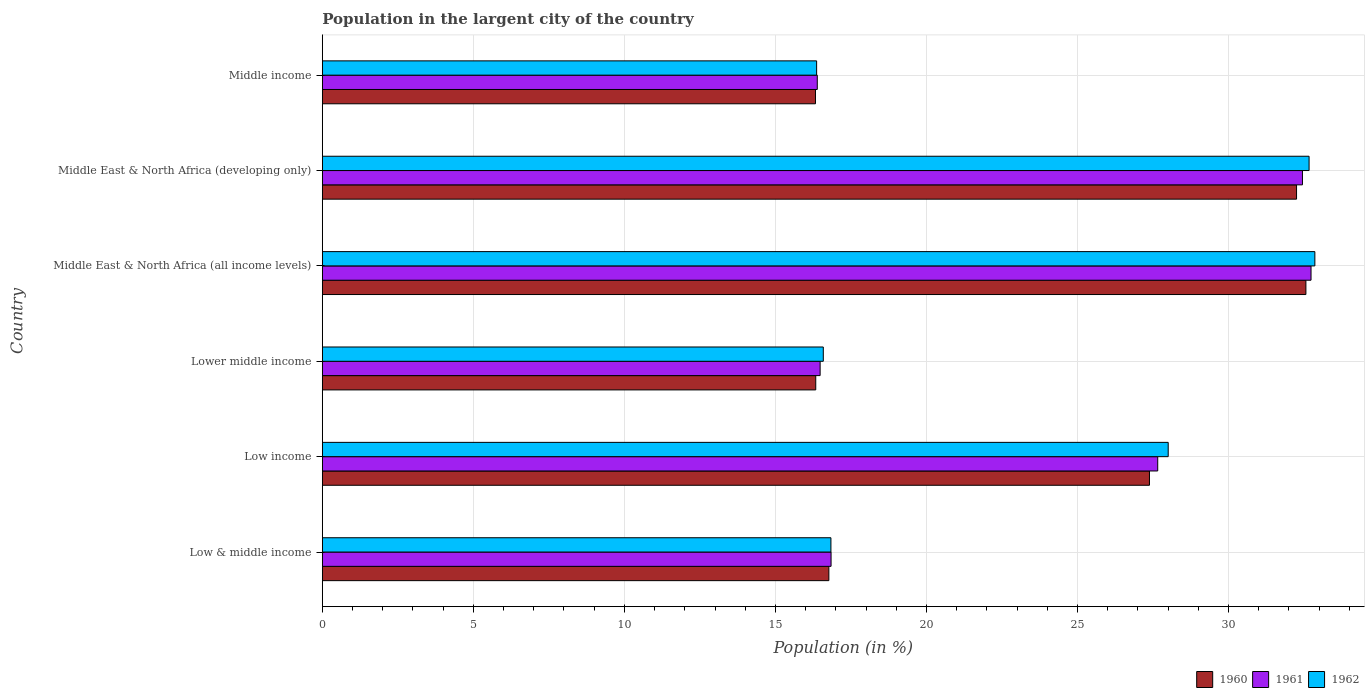How many different coloured bars are there?
Your response must be concise. 3. How many groups of bars are there?
Offer a terse response. 6. Are the number of bars on each tick of the Y-axis equal?
Give a very brief answer. Yes. What is the label of the 2nd group of bars from the top?
Keep it short and to the point. Middle East & North Africa (developing only). In how many cases, is the number of bars for a given country not equal to the number of legend labels?
Give a very brief answer. 0. What is the percentage of population in the largent city in 1962 in Middle East & North Africa (developing only)?
Provide a short and direct response. 32.67. Across all countries, what is the maximum percentage of population in the largent city in 1960?
Your response must be concise. 32.56. Across all countries, what is the minimum percentage of population in the largent city in 1962?
Keep it short and to the point. 16.36. In which country was the percentage of population in the largent city in 1961 maximum?
Provide a succinct answer. Middle East & North Africa (all income levels). In which country was the percentage of population in the largent city in 1962 minimum?
Your response must be concise. Middle income. What is the total percentage of population in the largent city in 1961 in the graph?
Offer a very short reply. 142.55. What is the difference between the percentage of population in the largent city in 1962 in Lower middle income and that in Middle income?
Your response must be concise. 0.22. What is the difference between the percentage of population in the largent city in 1962 in Middle income and the percentage of population in the largent city in 1960 in Low & middle income?
Your answer should be compact. -0.41. What is the average percentage of population in the largent city in 1960 per country?
Offer a terse response. 23.61. What is the difference between the percentage of population in the largent city in 1962 and percentage of population in the largent city in 1960 in Low income?
Give a very brief answer. 0.62. What is the ratio of the percentage of population in the largent city in 1960 in Low & middle income to that in Lower middle income?
Give a very brief answer. 1.03. Is the percentage of population in the largent city in 1960 in Low income less than that in Lower middle income?
Your answer should be compact. No. What is the difference between the highest and the second highest percentage of population in the largent city in 1961?
Keep it short and to the point. 0.28. What is the difference between the highest and the lowest percentage of population in the largent city in 1962?
Provide a short and direct response. 16.5. Is the sum of the percentage of population in the largent city in 1960 in Low & middle income and Middle East & North Africa (developing only) greater than the maximum percentage of population in the largent city in 1962 across all countries?
Keep it short and to the point. Yes. What does the 2nd bar from the top in Lower middle income represents?
Keep it short and to the point. 1961. What does the 1st bar from the bottom in Low income represents?
Your answer should be very brief. 1960. How many bars are there?
Provide a short and direct response. 18. How many countries are there in the graph?
Provide a succinct answer. 6. What is the difference between two consecutive major ticks on the X-axis?
Give a very brief answer. 5. Are the values on the major ticks of X-axis written in scientific E-notation?
Offer a terse response. No. How many legend labels are there?
Your answer should be very brief. 3. How are the legend labels stacked?
Ensure brevity in your answer.  Horizontal. What is the title of the graph?
Ensure brevity in your answer.  Population in the largent city of the country. Does "2010" appear as one of the legend labels in the graph?
Your response must be concise. No. What is the Population (in %) of 1960 in Low & middle income?
Provide a succinct answer. 16.77. What is the Population (in %) in 1961 in Low & middle income?
Offer a terse response. 16.84. What is the Population (in %) of 1962 in Low & middle income?
Offer a very short reply. 16.84. What is the Population (in %) of 1960 in Low income?
Make the answer very short. 27.38. What is the Population (in %) of 1961 in Low income?
Your response must be concise. 27.66. What is the Population (in %) of 1962 in Low income?
Provide a succinct answer. 28. What is the Population (in %) in 1960 in Lower middle income?
Ensure brevity in your answer.  16.34. What is the Population (in %) in 1961 in Lower middle income?
Ensure brevity in your answer.  16.48. What is the Population (in %) of 1962 in Lower middle income?
Offer a very short reply. 16.59. What is the Population (in %) of 1960 in Middle East & North Africa (all income levels)?
Keep it short and to the point. 32.56. What is the Population (in %) in 1961 in Middle East & North Africa (all income levels)?
Provide a short and direct response. 32.73. What is the Population (in %) of 1962 in Middle East & North Africa (all income levels)?
Your answer should be compact. 32.86. What is the Population (in %) in 1960 in Middle East & North Africa (developing only)?
Offer a terse response. 32.25. What is the Population (in %) in 1961 in Middle East & North Africa (developing only)?
Make the answer very short. 32.45. What is the Population (in %) of 1962 in Middle East & North Africa (developing only)?
Offer a terse response. 32.67. What is the Population (in %) of 1960 in Middle income?
Provide a succinct answer. 16.33. What is the Population (in %) of 1961 in Middle income?
Provide a succinct answer. 16.39. What is the Population (in %) in 1962 in Middle income?
Give a very brief answer. 16.36. Across all countries, what is the maximum Population (in %) of 1960?
Make the answer very short. 32.56. Across all countries, what is the maximum Population (in %) of 1961?
Ensure brevity in your answer.  32.73. Across all countries, what is the maximum Population (in %) of 1962?
Offer a terse response. 32.86. Across all countries, what is the minimum Population (in %) in 1960?
Offer a terse response. 16.33. Across all countries, what is the minimum Population (in %) of 1961?
Offer a terse response. 16.39. Across all countries, what is the minimum Population (in %) of 1962?
Provide a short and direct response. 16.36. What is the total Population (in %) of 1960 in the graph?
Your answer should be compact. 141.63. What is the total Population (in %) of 1961 in the graph?
Provide a succinct answer. 142.55. What is the total Population (in %) in 1962 in the graph?
Your answer should be very brief. 143.32. What is the difference between the Population (in %) of 1960 in Low & middle income and that in Low income?
Make the answer very short. -10.61. What is the difference between the Population (in %) in 1961 in Low & middle income and that in Low income?
Your response must be concise. -10.81. What is the difference between the Population (in %) in 1962 in Low & middle income and that in Low income?
Your answer should be very brief. -11.17. What is the difference between the Population (in %) in 1960 in Low & middle income and that in Lower middle income?
Keep it short and to the point. 0.43. What is the difference between the Population (in %) in 1961 in Low & middle income and that in Lower middle income?
Offer a terse response. 0.36. What is the difference between the Population (in %) in 1962 in Low & middle income and that in Lower middle income?
Provide a short and direct response. 0.25. What is the difference between the Population (in %) in 1960 in Low & middle income and that in Middle East & North Africa (all income levels)?
Offer a very short reply. -15.79. What is the difference between the Population (in %) of 1961 in Low & middle income and that in Middle East & North Africa (all income levels)?
Offer a very short reply. -15.89. What is the difference between the Population (in %) in 1962 in Low & middle income and that in Middle East & North Africa (all income levels)?
Provide a succinct answer. -16.02. What is the difference between the Population (in %) of 1960 in Low & middle income and that in Middle East & North Africa (developing only)?
Offer a very short reply. -15.48. What is the difference between the Population (in %) in 1961 in Low & middle income and that in Middle East & North Africa (developing only)?
Your answer should be compact. -15.61. What is the difference between the Population (in %) in 1962 in Low & middle income and that in Middle East & North Africa (developing only)?
Your answer should be compact. -15.83. What is the difference between the Population (in %) of 1960 in Low & middle income and that in Middle income?
Keep it short and to the point. 0.44. What is the difference between the Population (in %) in 1961 in Low & middle income and that in Middle income?
Offer a very short reply. 0.46. What is the difference between the Population (in %) in 1962 in Low & middle income and that in Middle income?
Your response must be concise. 0.47. What is the difference between the Population (in %) of 1960 in Low income and that in Lower middle income?
Your response must be concise. 11.05. What is the difference between the Population (in %) of 1961 in Low income and that in Lower middle income?
Give a very brief answer. 11.18. What is the difference between the Population (in %) of 1962 in Low income and that in Lower middle income?
Provide a short and direct response. 11.42. What is the difference between the Population (in %) in 1960 in Low income and that in Middle East & North Africa (all income levels)?
Offer a terse response. -5.18. What is the difference between the Population (in %) in 1961 in Low income and that in Middle East & North Africa (all income levels)?
Your answer should be very brief. -5.08. What is the difference between the Population (in %) of 1962 in Low income and that in Middle East & North Africa (all income levels)?
Your answer should be compact. -4.86. What is the difference between the Population (in %) in 1960 in Low income and that in Middle East & North Africa (developing only)?
Offer a terse response. -4.87. What is the difference between the Population (in %) of 1961 in Low income and that in Middle East & North Africa (developing only)?
Ensure brevity in your answer.  -4.79. What is the difference between the Population (in %) in 1962 in Low income and that in Middle East & North Africa (developing only)?
Provide a succinct answer. -4.66. What is the difference between the Population (in %) of 1960 in Low income and that in Middle income?
Provide a short and direct response. 11.06. What is the difference between the Population (in %) in 1961 in Low income and that in Middle income?
Offer a terse response. 11.27. What is the difference between the Population (in %) in 1962 in Low income and that in Middle income?
Give a very brief answer. 11.64. What is the difference between the Population (in %) of 1960 in Lower middle income and that in Middle East & North Africa (all income levels)?
Ensure brevity in your answer.  -16.23. What is the difference between the Population (in %) in 1961 in Lower middle income and that in Middle East & North Africa (all income levels)?
Ensure brevity in your answer.  -16.25. What is the difference between the Population (in %) of 1962 in Lower middle income and that in Middle East & North Africa (all income levels)?
Offer a very short reply. -16.27. What is the difference between the Population (in %) in 1960 in Lower middle income and that in Middle East & North Africa (developing only)?
Ensure brevity in your answer.  -15.92. What is the difference between the Population (in %) of 1961 in Lower middle income and that in Middle East & North Africa (developing only)?
Make the answer very short. -15.97. What is the difference between the Population (in %) in 1962 in Lower middle income and that in Middle East & North Africa (developing only)?
Provide a short and direct response. -16.08. What is the difference between the Population (in %) of 1960 in Lower middle income and that in Middle income?
Provide a short and direct response. 0.01. What is the difference between the Population (in %) of 1961 in Lower middle income and that in Middle income?
Make the answer very short. 0.09. What is the difference between the Population (in %) of 1962 in Lower middle income and that in Middle income?
Provide a short and direct response. 0.22. What is the difference between the Population (in %) in 1960 in Middle East & North Africa (all income levels) and that in Middle East & North Africa (developing only)?
Your answer should be compact. 0.31. What is the difference between the Population (in %) of 1961 in Middle East & North Africa (all income levels) and that in Middle East & North Africa (developing only)?
Offer a terse response. 0.28. What is the difference between the Population (in %) in 1962 in Middle East & North Africa (all income levels) and that in Middle East & North Africa (developing only)?
Keep it short and to the point. 0.19. What is the difference between the Population (in %) of 1960 in Middle East & North Africa (all income levels) and that in Middle income?
Provide a short and direct response. 16.24. What is the difference between the Population (in %) in 1961 in Middle East & North Africa (all income levels) and that in Middle income?
Your response must be concise. 16.35. What is the difference between the Population (in %) in 1962 in Middle East & North Africa (all income levels) and that in Middle income?
Make the answer very short. 16.5. What is the difference between the Population (in %) in 1960 in Middle East & North Africa (developing only) and that in Middle income?
Give a very brief answer. 15.93. What is the difference between the Population (in %) of 1961 in Middle East & North Africa (developing only) and that in Middle income?
Provide a short and direct response. 16.06. What is the difference between the Population (in %) of 1962 in Middle East & North Africa (developing only) and that in Middle income?
Your answer should be very brief. 16.3. What is the difference between the Population (in %) of 1960 in Low & middle income and the Population (in %) of 1961 in Low income?
Keep it short and to the point. -10.89. What is the difference between the Population (in %) of 1960 in Low & middle income and the Population (in %) of 1962 in Low income?
Provide a succinct answer. -11.23. What is the difference between the Population (in %) of 1961 in Low & middle income and the Population (in %) of 1962 in Low income?
Make the answer very short. -11.16. What is the difference between the Population (in %) of 1960 in Low & middle income and the Population (in %) of 1961 in Lower middle income?
Offer a very short reply. 0.29. What is the difference between the Population (in %) of 1960 in Low & middle income and the Population (in %) of 1962 in Lower middle income?
Your answer should be very brief. 0.18. What is the difference between the Population (in %) in 1961 in Low & middle income and the Population (in %) in 1962 in Lower middle income?
Provide a succinct answer. 0.26. What is the difference between the Population (in %) of 1960 in Low & middle income and the Population (in %) of 1961 in Middle East & North Africa (all income levels)?
Offer a terse response. -15.96. What is the difference between the Population (in %) of 1960 in Low & middle income and the Population (in %) of 1962 in Middle East & North Africa (all income levels)?
Provide a short and direct response. -16.09. What is the difference between the Population (in %) in 1961 in Low & middle income and the Population (in %) in 1962 in Middle East & North Africa (all income levels)?
Provide a short and direct response. -16.02. What is the difference between the Population (in %) in 1960 in Low & middle income and the Population (in %) in 1961 in Middle East & North Africa (developing only)?
Offer a terse response. -15.68. What is the difference between the Population (in %) in 1960 in Low & middle income and the Population (in %) in 1962 in Middle East & North Africa (developing only)?
Provide a succinct answer. -15.9. What is the difference between the Population (in %) in 1961 in Low & middle income and the Population (in %) in 1962 in Middle East & North Africa (developing only)?
Keep it short and to the point. -15.83. What is the difference between the Population (in %) in 1960 in Low & middle income and the Population (in %) in 1961 in Middle income?
Make the answer very short. 0.38. What is the difference between the Population (in %) of 1960 in Low & middle income and the Population (in %) of 1962 in Middle income?
Give a very brief answer. 0.41. What is the difference between the Population (in %) in 1961 in Low & middle income and the Population (in %) in 1962 in Middle income?
Make the answer very short. 0.48. What is the difference between the Population (in %) of 1960 in Low income and the Population (in %) of 1961 in Lower middle income?
Make the answer very short. 10.9. What is the difference between the Population (in %) in 1960 in Low income and the Population (in %) in 1962 in Lower middle income?
Keep it short and to the point. 10.8. What is the difference between the Population (in %) in 1961 in Low income and the Population (in %) in 1962 in Lower middle income?
Ensure brevity in your answer.  11.07. What is the difference between the Population (in %) in 1960 in Low income and the Population (in %) in 1961 in Middle East & North Africa (all income levels)?
Your answer should be very brief. -5.35. What is the difference between the Population (in %) in 1960 in Low income and the Population (in %) in 1962 in Middle East & North Africa (all income levels)?
Your answer should be compact. -5.48. What is the difference between the Population (in %) of 1961 in Low income and the Population (in %) of 1962 in Middle East & North Africa (all income levels)?
Offer a very short reply. -5.2. What is the difference between the Population (in %) in 1960 in Low income and the Population (in %) in 1961 in Middle East & North Africa (developing only)?
Offer a terse response. -5.07. What is the difference between the Population (in %) of 1960 in Low income and the Population (in %) of 1962 in Middle East & North Africa (developing only)?
Keep it short and to the point. -5.28. What is the difference between the Population (in %) of 1961 in Low income and the Population (in %) of 1962 in Middle East & North Africa (developing only)?
Give a very brief answer. -5.01. What is the difference between the Population (in %) in 1960 in Low income and the Population (in %) in 1961 in Middle income?
Give a very brief answer. 11. What is the difference between the Population (in %) of 1960 in Low income and the Population (in %) of 1962 in Middle income?
Your answer should be very brief. 11.02. What is the difference between the Population (in %) of 1961 in Low income and the Population (in %) of 1962 in Middle income?
Your answer should be compact. 11.29. What is the difference between the Population (in %) of 1960 in Lower middle income and the Population (in %) of 1961 in Middle East & North Africa (all income levels)?
Keep it short and to the point. -16.4. What is the difference between the Population (in %) in 1960 in Lower middle income and the Population (in %) in 1962 in Middle East & North Africa (all income levels)?
Ensure brevity in your answer.  -16.52. What is the difference between the Population (in %) of 1961 in Lower middle income and the Population (in %) of 1962 in Middle East & North Africa (all income levels)?
Provide a short and direct response. -16.38. What is the difference between the Population (in %) of 1960 in Lower middle income and the Population (in %) of 1961 in Middle East & North Africa (developing only)?
Give a very brief answer. -16.11. What is the difference between the Population (in %) in 1960 in Lower middle income and the Population (in %) in 1962 in Middle East & North Africa (developing only)?
Provide a succinct answer. -16.33. What is the difference between the Population (in %) of 1961 in Lower middle income and the Population (in %) of 1962 in Middle East & North Africa (developing only)?
Provide a short and direct response. -16.19. What is the difference between the Population (in %) in 1960 in Lower middle income and the Population (in %) in 1961 in Middle income?
Make the answer very short. -0.05. What is the difference between the Population (in %) in 1960 in Lower middle income and the Population (in %) in 1962 in Middle income?
Make the answer very short. -0.03. What is the difference between the Population (in %) in 1961 in Lower middle income and the Population (in %) in 1962 in Middle income?
Offer a terse response. 0.12. What is the difference between the Population (in %) in 1960 in Middle East & North Africa (all income levels) and the Population (in %) in 1961 in Middle East & North Africa (developing only)?
Offer a terse response. 0.11. What is the difference between the Population (in %) of 1960 in Middle East & North Africa (all income levels) and the Population (in %) of 1962 in Middle East & North Africa (developing only)?
Offer a terse response. -0.1. What is the difference between the Population (in %) of 1961 in Middle East & North Africa (all income levels) and the Population (in %) of 1962 in Middle East & North Africa (developing only)?
Offer a very short reply. 0.06. What is the difference between the Population (in %) of 1960 in Middle East & North Africa (all income levels) and the Population (in %) of 1961 in Middle income?
Provide a succinct answer. 16.18. What is the difference between the Population (in %) in 1960 in Middle East & North Africa (all income levels) and the Population (in %) in 1962 in Middle income?
Provide a succinct answer. 16.2. What is the difference between the Population (in %) in 1961 in Middle East & North Africa (all income levels) and the Population (in %) in 1962 in Middle income?
Your answer should be compact. 16.37. What is the difference between the Population (in %) of 1960 in Middle East & North Africa (developing only) and the Population (in %) of 1961 in Middle income?
Provide a succinct answer. 15.87. What is the difference between the Population (in %) in 1960 in Middle East & North Africa (developing only) and the Population (in %) in 1962 in Middle income?
Ensure brevity in your answer.  15.89. What is the difference between the Population (in %) of 1961 in Middle East & North Africa (developing only) and the Population (in %) of 1962 in Middle income?
Your answer should be compact. 16.08. What is the average Population (in %) in 1960 per country?
Ensure brevity in your answer.  23.61. What is the average Population (in %) in 1961 per country?
Give a very brief answer. 23.76. What is the average Population (in %) of 1962 per country?
Make the answer very short. 23.89. What is the difference between the Population (in %) of 1960 and Population (in %) of 1961 in Low & middle income?
Provide a short and direct response. -0.07. What is the difference between the Population (in %) of 1960 and Population (in %) of 1962 in Low & middle income?
Offer a terse response. -0.07. What is the difference between the Population (in %) of 1961 and Population (in %) of 1962 in Low & middle income?
Make the answer very short. 0. What is the difference between the Population (in %) in 1960 and Population (in %) in 1961 in Low income?
Your answer should be very brief. -0.27. What is the difference between the Population (in %) in 1960 and Population (in %) in 1962 in Low income?
Keep it short and to the point. -0.62. What is the difference between the Population (in %) in 1961 and Population (in %) in 1962 in Low income?
Your answer should be very brief. -0.35. What is the difference between the Population (in %) of 1960 and Population (in %) of 1961 in Lower middle income?
Make the answer very short. -0.15. What is the difference between the Population (in %) of 1960 and Population (in %) of 1962 in Lower middle income?
Ensure brevity in your answer.  -0.25. What is the difference between the Population (in %) of 1961 and Population (in %) of 1962 in Lower middle income?
Your answer should be compact. -0.1. What is the difference between the Population (in %) in 1960 and Population (in %) in 1961 in Middle East & North Africa (all income levels)?
Your answer should be very brief. -0.17. What is the difference between the Population (in %) in 1960 and Population (in %) in 1962 in Middle East & North Africa (all income levels)?
Offer a terse response. -0.3. What is the difference between the Population (in %) in 1961 and Population (in %) in 1962 in Middle East & North Africa (all income levels)?
Make the answer very short. -0.13. What is the difference between the Population (in %) in 1960 and Population (in %) in 1961 in Middle East & North Africa (developing only)?
Keep it short and to the point. -0.2. What is the difference between the Population (in %) of 1960 and Population (in %) of 1962 in Middle East & North Africa (developing only)?
Offer a terse response. -0.41. What is the difference between the Population (in %) of 1961 and Population (in %) of 1962 in Middle East & North Africa (developing only)?
Offer a very short reply. -0.22. What is the difference between the Population (in %) of 1960 and Population (in %) of 1961 in Middle income?
Provide a short and direct response. -0.06. What is the difference between the Population (in %) of 1960 and Population (in %) of 1962 in Middle income?
Provide a short and direct response. -0.04. What is the difference between the Population (in %) of 1961 and Population (in %) of 1962 in Middle income?
Ensure brevity in your answer.  0.02. What is the ratio of the Population (in %) of 1960 in Low & middle income to that in Low income?
Your response must be concise. 0.61. What is the ratio of the Population (in %) of 1961 in Low & middle income to that in Low income?
Offer a terse response. 0.61. What is the ratio of the Population (in %) in 1962 in Low & middle income to that in Low income?
Provide a succinct answer. 0.6. What is the ratio of the Population (in %) in 1960 in Low & middle income to that in Lower middle income?
Provide a short and direct response. 1.03. What is the ratio of the Population (in %) of 1962 in Low & middle income to that in Lower middle income?
Make the answer very short. 1.02. What is the ratio of the Population (in %) of 1960 in Low & middle income to that in Middle East & North Africa (all income levels)?
Make the answer very short. 0.52. What is the ratio of the Population (in %) in 1961 in Low & middle income to that in Middle East & North Africa (all income levels)?
Your answer should be very brief. 0.51. What is the ratio of the Population (in %) in 1962 in Low & middle income to that in Middle East & North Africa (all income levels)?
Offer a terse response. 0.51. What is the ratio of the Population (in %) in 1960 in Low & middle income to that in Middle East & North Africa (developing only)?
Provide a succinct answer. 0.52. What is the ratio of the Population (in %) of 1961 in Low & middle income to that in Middle East & North Africa (developing only)?
Give a very brief answer. 0.52. What is the ratio of the Population (in %) in 1962 in Low & middle income to that in Middle East & North Africa (developing only)?
Make the answer very short. 0.52. What is the ratio of the Population (in %) in 1960 in Low & middle income to that in Middle income?
Your answer should be very brief. 1.03. What is the ratio of the Population (in %) in 1961 in Low & middle income to that in Middle income?
Make the answer very short. 1.03. What is the ratio of the Population (in %) in 1962 in Low & middle income to that in Middle income?
Keep it short and to the point. 1.03. What is the ratio of the Population (in %) of 1960 in Low income to that in Lower middle income?
Give a very brief answer. 1.68. What is the ratio of the Population (in %) of 1961 in Low income to that in Lower middle income?
Your response must be concise. 1.68. What is the ratio of the Population (in %) in 1962 in Low income to that in Lower middle income?
Provide a short and direct response. 1.69. What is the ratio of the Population (in %) of 1960 in Low income to that in Middle East & North Africa (all income levels)?
Give a very brief answer. 0.84. What is the ratio of the Population (in %) of 1961 in Low income to that in Middle East & North Africa (all income levels)?
Ensure brevity in your answer.  0.84. What is the ratio of the Population (in %) in 1962 in Low income to that in Middle East & North Africa (all income levels)?
Keep it short and to the point. 0.85. What is the ratio of the Population (in %) in 1960 in Low income to that in Middle East & North Africa (developing only)?
Your response must be concise. 0.85. What is the ratio of the Population (in %) in 1961 in Low income to that in Middle East & North Africa (developing only)?
Your answer should be very brief. 0.85. What is the ratio of the Population (in %) of 1962 in Low income to that in Middle East & North Africa (developing only)?
Provide a short and direct response. 0.86. What is the ratio of the Population (in %) in 1960 in Low income to that in Middle income?
Make the answer very short. 1.68. What is the ratio of the Population (in %) of 1961 in Low income to that in Middle income?
Keep it short and to the point. 1.69. What is the ratio of the Population (in %) in 1962 in Low income to that in Middle income?
Your answer should be very brief. 1.71. What is the ratio of the Population (in %) in 1960 in Lower middle income to that in Middle East & North Africa (all income levels)?
Provide a succinct answer. 0.5. What is the ratio of the Population (in %) of 1961 in Lower middle income to that in Middle East & North Africa (all income levels)?
Your response must be concise. 0.5. What is the ratio of the Population (in %) in 1962 in Lower middle income to that in Middle East & North Africa (all income levels)?
Your answer should be compact. 0.5. What is the ratio of the Population (in %) in 1960 in Lower middle income to that in Middle East & North Africa (developing only)?
Ensure brevity in your answer.  0.51. What is the ratio of the Population (in %) of 1961 in Lower middle income to that in Middle East & North Africa (developing only)?
Make the answer very short. 0.51. What is the ratio of the Population (in %) in 1962 in Lower middle income to that in Middle East & North Africa (developing only)?
Provide a short and direct response. 0.51. What is the ratio of the Population (in %) of 1962 in Lower middle income to that in Middle income?
Offer a very short reply. 1.01. What is the ratio of the Population (in %) in 1960 in Middle East & North Africa (all income levels) to that in Middle East & North Africa (developing only)?
Keep it short and to the point. 1.01. What is the ratio of the Population (in %) of 1961 in Middle East & North Africa (all income levels) to that in Middle East & North Africa (developing only)?
Your response must be concise. 1.01. What is the ratio of the Population (in %) of 1962 in Middle East & North Africa (all income levels) to that in Middle East & North Africa (developing only)?
Your response must be concise. 1.01. What is the ratio of the Population (in %) of 1960 in Middle East & North Africa (all income levels) to that in Middle income?
Your answer should be very brief. 1.99. What is the ratio of the Population (in %) of 1961 in Middle East & North Africa (all income levels) to that in Middle income?
Give a very brief answer. 2. What is the ratio of the Population (in %) in 1962 in Middle East & North Africa (all income levels) to that in Middle income?
Offer a terse response. 2.01. What is the ratio of the Population (in %) of 1960 in Middle East & North Africa (developing only) to that in Middle income?
Your answer should be very brief. 1.98. What is the ratio of the Population (in %) of 1961 in Middle East & North Africa (developing only) to that in Middle income?
Your response must be concise. 1.98. What is the ratio of the Population (in %) of 1962 in Middle East & North Africa (developing only) to that in Middle income?
Your answer should be compact. 2. What is the difference between the highest and the second highest Population (in %) of 1960?
Your answer should be compact. 0.31. What is the difference between the highest and the second highest Population (in %) of 1961?
Ensure brevity in your answer.  0.28. What is the difference between the highest and the second highest Population (in %) of 1962?
Provide a short and direct response. 0.19. What is the difference between the highest and the lowest Population (in %) in 1960?
Offer a terse response. 16.24. What is the difference between the highest and the lowest Population (in %) in 1961?
Your answer should be very brief. 16.35. What is the difference between the highest and the lowest Population (in %) in 1962?
Keep it short and to the point. 16.5. 